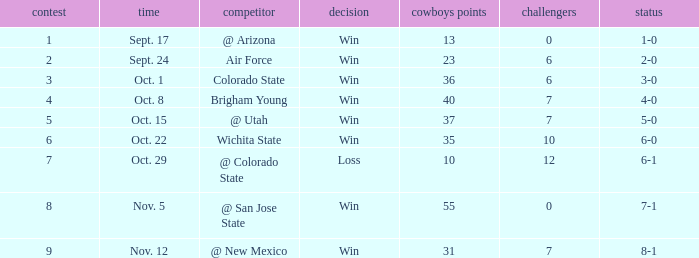When did the Cowboys score 13 points in 1966? Sept. 17. 